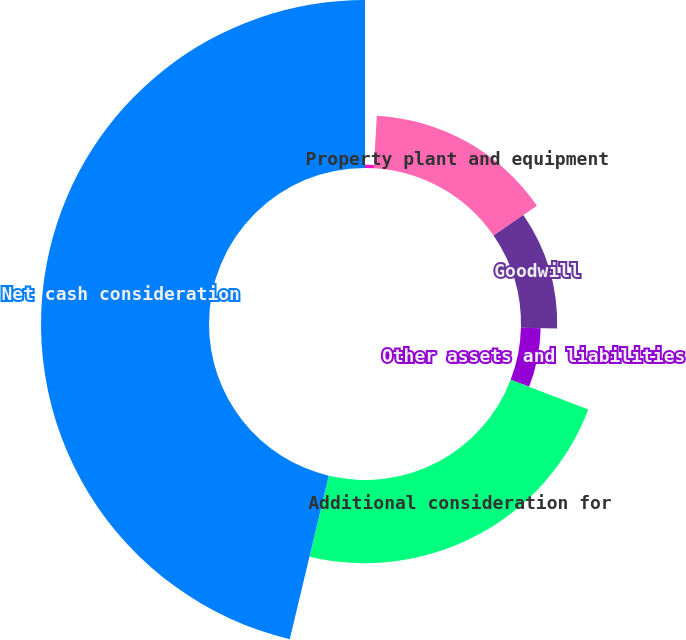Convert chart to OTSL. <chart><loc_0><loc_0><loc_500><loc_500><pie_chart><fcel>Inventory<fcel>Property plant and equipment<fcel>Goodwill<fcel>Other assets and liabilities<fcel>Additional consideration for<fcel>Net cash consideration<nl><fcel>0.9%<fcel>14.51%<fcel>9.97%<fcel>5.44%<fcel>22.91%<fcel>46.27%<nl></chart> 